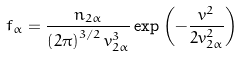<formula> <loc_0><loc_0><loc_500><loc_500>f _ { \alpha } = \frac { n _ { 2 \alpha } } { \left ( 2 \pi \right ) ^ { 3 / 2 } v _ { 2 \alpha } ^ { 3 } } \exp \left ( - \frac { v ^ { 2 } } { 2 v _ { 2 \alpha } ^ { 2 } } \right )</formula> 